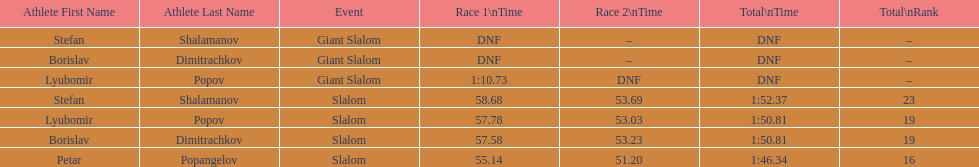What is the number of athletes to finish race one in the giant slalom? 1. 